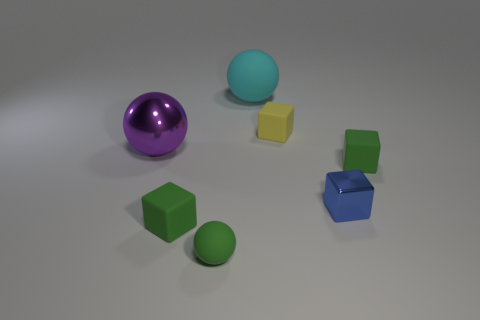Is the green block that is right of the yellow thing made of the same material as the large sphere to the right of the large purple metallic sphere?
Offer a very short reply. Yes. There is a green matte block that is left of the small green block to the right of the big matte thing; how many small things are on the right side of it?
Make the answer very short. 4. There is a matte cube that is left of the cyan rubber ball; does it have the same color as the big ball in front of the cyan ball?
Provide a succinct answer. No. Is there any other thing that has the same color as the large metal object?
Offer a very short reply. No. The big sphere that is on the left side of the big object to the right of the large purple metal ball is what color?
Give a very brief answer. Purple. Are any small blue metallic cubes visible?
Keep it short and to the point. Yes. What is the color of the tiny thing that is behind the small green matte ball and left of the yellow matte object?
Your response must be concise. Green. Is the size of the yellow matte block that is in front of the big cyan rubber object the same as the metal object that is on the right side of the purple ball?
Keep it short and to the point. Yes. How many other objects are there of the same size as the yellow rubber object?
Your response must be concise. 4. There is a small thing that is behind the big metal sphere; how many tiny metallic things are to the right of it?
Provide a short and direct response. 1. 